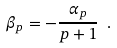<formula> <loc_0><loc_0><loc_500><loc_500>\beta _ { p } = - \frac { \alpha _ { p } } { p + 1 } \ .</formula> 